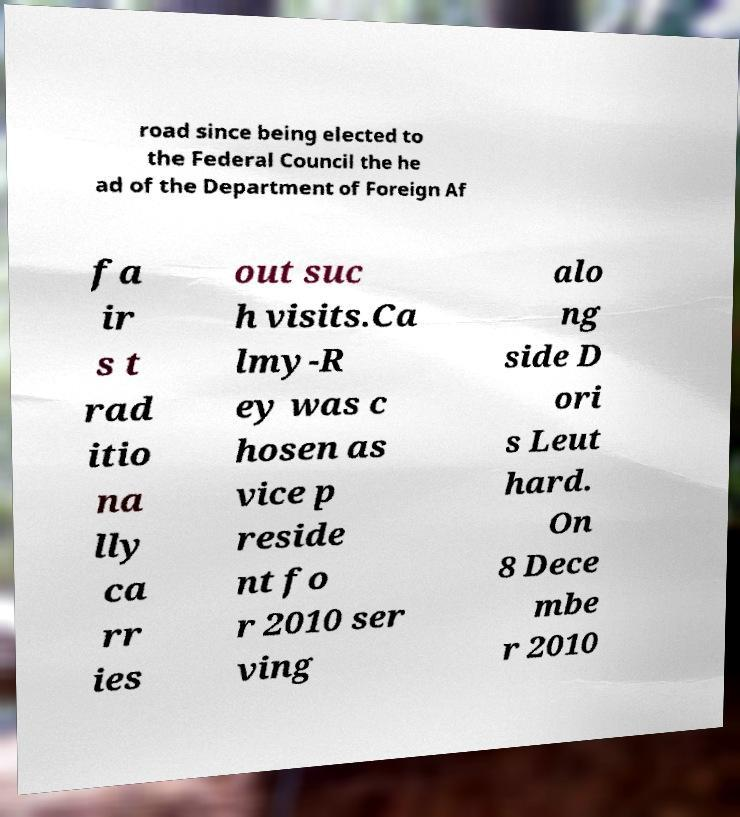Please identify and transcribe the text found in this image. road since being elected to the Federal Council the he ad of the Department of Foreign Af fa ir s t rad itio na lly ca rr ies out suc h visits.Ca lmy-R ey was c hosen as vice p reside nt fo r 2010 ser ving alo ng side D ori s Leut hard. On 8 Dece mbe r 2010 